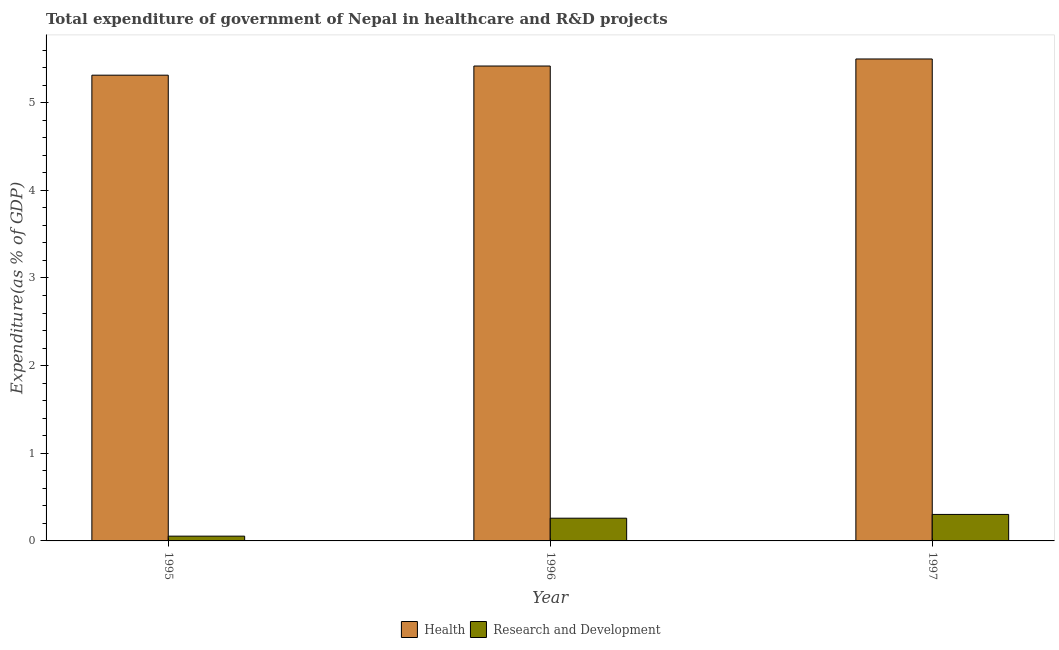How many different coloured bars are there?
Ensure brevity in your answer.  2. Are the number of bars per tick equal to the number of legend labels?
Provide a succinct answer. Yes. Are the number of bars on each tick of the X-axis equal?
Make the answer very short. Yes. How many bars are there on the 1st tick from the right?
Make the answer very short. 2. What is the label of the 3rd group of bars from the left?
Provide a succinct answer. 1997. What is the expenditure in r&d in 1996?
Offer a terse response. 0.26. Across all years, what is the maximum expenditure in healthcare?
Give a very brief answer. 5.5. Across all years, what is the minimum expenditure in r&d?
Give a very brief answer. 0.05. In which year was the expenditure in r&d maximum?
Provide a succinct answer. 1997. In which year was the expenditure in r&d minimum?
Make the answer very short. 1995. What is the total expenditure in r&d in the graph?
Give a very brief answer. 0.62. What is the difference between the expenditure in healthcare in 1995 and that in 1997?
Your response must be concise. -0.18. What is the difference between the expenditure in r&d in 1995 and the expenditure in healthcare in 1996?
Keep it short and to the point. -0.2. What is the average expenditure in healthcare per year?
Give a very brief answer. 5.41. In how many years, is the expenditure in healthcare greater than 1.6 %?
Your answer should be very brief. 3. What is the ratio of the expenditure in healthcare in 1995 to that in 1996?
Make the answer very short. 0.98. Is the difference between the expenditure in r&d in 1995 and 1996 greater than the difference between the expenditure in healthcare in 1995 and 1996?
Keep it short and to the point. No. What is the difference between the highest and the second highest expenditure in healthcare?
Your answer should be compact. 0.08. What is the difference between the highest and the lowest expenditure in r&d?
Provide a short and direct response. 0.25. In how many years, is the expenditure in healthcare greater than the average expenditure in healthcare taken over all years?
Your answer should be compact. 2. What does the 1st bar from the left in 1997 represents?
Make the answer very short. Health. What does the 1st bar from the right in 1995 represents?
Ensure brevity in your answer.  Research and Development. How many bars are there?
Keep it short and to the point. 6. How many years are there in the graph?
Offer a terse response. 3. What is the difference between two consecutive major ticks on the Y-axis?
Your answer should be compact. 1. Does the graph contain any zero values?
Provide a short and direct response. No. How many legend labels are there?
Give a very brief answer. 2. How are the legend labels stacked?
Offer a very short reply. Horizontal. What is the title of the graph?
Offer a very short reply. Total expenditure of government of Nepal in healthcare and R&D projects. Does "Methane" appear as one of the legend labels in the graph?
Give a very brief answer. No. What is the label or title of the X-axis?
Provide a succinct answer. Year. What is the label or title of the Y-axis?
Make the answer very short. Expenditure(as % of GDP). What is the Expenditure(as % of GDP) in Health in 1995?
Offer a terse response. 5.31. What is the Expenditure(as % of GDP) in Research and Development in 1995?
Offer a terse response. 0.05. What is the Expenditure(as % of GDP) in Health in 1996?
Your answer should be very brief. 5.42. What is the Expenditure(as % of GDP) in Research and Development in 1996?
Provide a succinct answer. 0.26. What is the Expenditure(as % of GDP) of Health in 1997?
Your response must be concise. 5.5. What is the Expenditure(as % of GDP) in Research and Development in 1997?
Provide a succinct answer. 0.3. Across all years, what is the maximum Expenditure(as % of GDP) in Health?
Offer a very short reply. 5.5. Across all years, what is the maximum Expenditure(as % of GDP) of Research and Development?
Offer a very short reply. 0.3. Across all years, what is the minimum Expenditure(as % of GDP) in Health?
Give a very brief answer. 5.31. Across all years, what is the minimum Expenditure(as % of GDP) in Research and Development?
Offer a very short reply. 0.05. What is the total Expenditure(as % of GDP) of Health in the graph?
Keep it short and to the point. 16.23. What is the total Expenditure(as % of GDP) of Research and Development in the graph?
Offer a terse response. 0.62. What is the difference between the Expenditure(as % of GDP) of Health in 1995 and that in 1996?
Keep it short and to the point. -0.1. What is the difference between the Expenditure(as % of GDP) in Research and Development in 1995 and that in 1996?
Ensure brevity in your answer.  -0.2. What is the difference between the Expenditure(as % of GDP) of Health in 1995 and that in 1997?
Your answer should be compact. -0.18. What is the difference between the Expenditure(as % of GDP) of Research and Development in 1995 and that in 1997?
Give a very brief answer. -0.25. What is the difference between the Expenditure(as % of GDP) of Health in 1996 and that in 1997?
Make the answer very short. -0.08. What is the difference between the Expenditure(as % of GDP) in Research and Development in 1996 and that in 1997?
Give a very brief answer. -0.04. What is the difference between the Expenditure(as % of GDP) in Health in 1995 and the Expenditure(as % of GDP) in Research and Development in 1996?
Make the answer very short. 5.05. What is the difference between the Expenditure(as % of GDP) in Health in 1995 and the Expenditure(as % of GDP) in Research and Development in 1997?
Ensure brevity in your answer.  5.01. What is the difference between the Expenditure(as % of GDP) of Health in 1996 and the Expenditure(as % of GDP) of Research and Development in 1997?
Offer a very short reply. 5.12. What is the average Expenditure(as % of GDP) in Health per year?
Make the answer very short. 5.41. What is the average Expenditure(as % of GDP) in Research and Development per year?
Give a very brief answer. 0.21. In the year 1995, what is the difference between the Expenditure(as % of GDP) of Health and Expenditure(as % of GDP) of Research and Development?
Keep it short and to the point. 5.26. In the year 1996, what is the difference between the Expenditure(as % of GDP) of Health and Expenditure(as % of GDP) of Research and Development?
Your answer should be very brief. 5.16. In the year 1997, what is the difference between the Expenditure(as % of GDP) of Health and Expenditure(as % of GDP) of Research and Development?
Ensure brevity in your answer.  5.2. What is the ratio of the Expenditure(as % of GDP) in Health in 1995 to that in 1996?
Your answer should be compact. 0.98. What is the ratio of the Expenditure(as % of GDP) of Research and Development in 1995 to that in 1996?
Provide a succinct answer. 0.21. What is the ratio of the Expenditure(as % of GDP) in Health in 1995 to that in 1997?
Give a very brief answer. 0.97. What is the ratio of the Expenditure(as % of GDP) in Research and Development in 1995 to that in 1997?
Your answer should be compact. 0.18. What is the ratio of the Expenditure(as % of GDP) in Health in 1996 to that in 1997?
Offer a very short reply. 0.99. What is the ratio of the Expenditure(as % of GDP) in Research and Development in 1996 to that in 1997?
Offer a terse response. 0.86. What is the difference between the highest and the second highest Expenditure(as % of GDP) of Health?
Give a very brief answer. 0.08. What is the difference between the highest and the second highest Expenditure(as % of GDP) in Research and Development?
Offer a very short reply. 0.04. What is the difference between the highest and the lowest Expenditure(as % of GDP) of Health?
Your answer should be very brief. 0.18. What is the difference between the highest and the lowest Expenditure(as % of GDP) in Research and Development?
Ensure brevity in your answer.  0.25. 